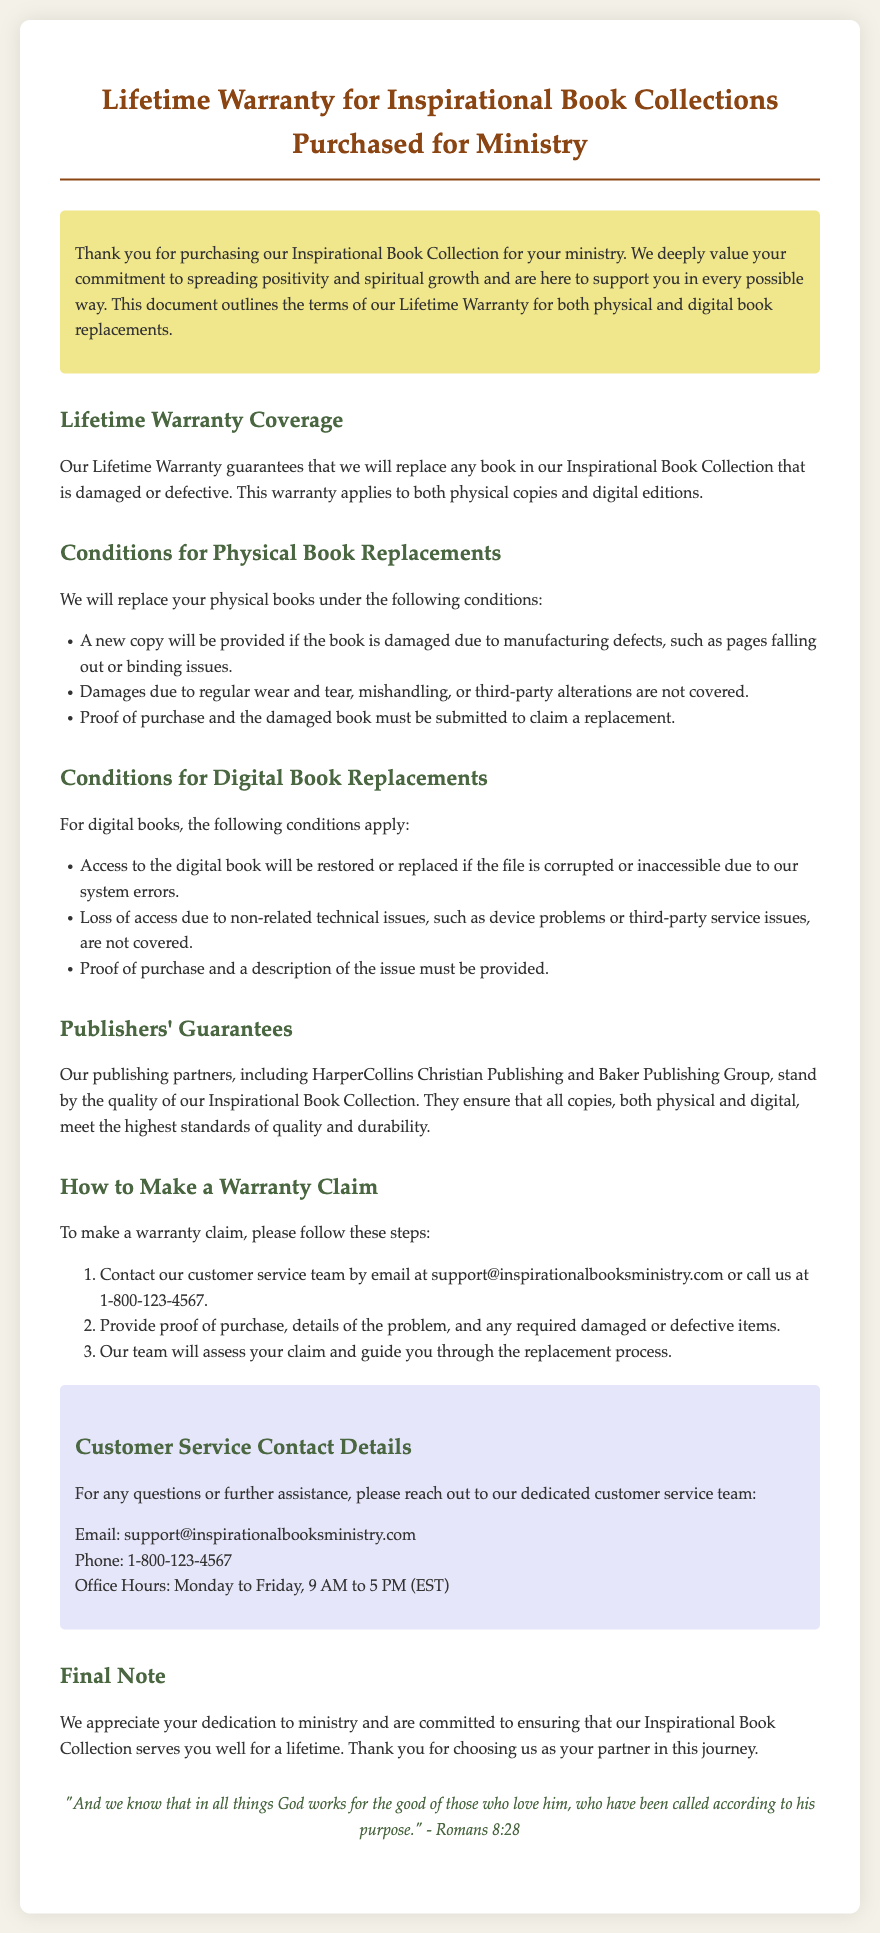What does the Lifetime Warranty cover? The Lifetime Warranty guarantees that we will replace any book in our Inspirational Book Collection that is damaged or defective.
Answer: Replacement of damaged or defective books What is the email address for customer service? The document provides a specific email for customer service inquiries regarding warranty claims.
Answer: support@inspirationalbooksministry.com What must be provided to claim a physical book replacement? The document states requirements for claiming a physical book replacement, which includes specific items that must be provided.
Answer: Proof of purchase and the damaged book Who are the publishers mentioned in the warranty? The document refers to specific publishers that endorse the quality of the Inspirational Book Collection.
Answer: HarperCollins Christian Publishing and Baker Publishing Group What is the phone number for customer service? A contact number is given for customers seeking assistance with warranty claims.
Answer: 1-800-123-4567 Under which condition will digital books be replaced? The document lists specific conditions under which a digital book replacement will be processed.
Answer: If the file is corrupted or inaccessible due to system errors What type of damages are not covered for physical books? The document outlines what types of damages will not be replaced, specifically indicating exclusions.
Answer: Regular wear and tear, mishandling, or third-party alterations When are customer service office hours? The warranty document specifies the operating hours of the customer service team.
Answer: Monday to Friday, 9 AM to 5 PM (EST) 